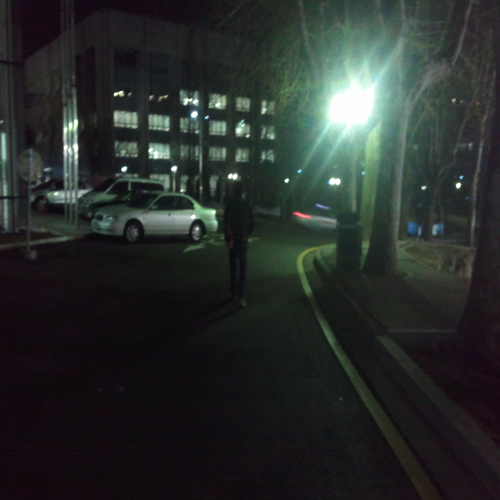Is the overall clarity of the image low? Indeed, the overall clarity of the image is low; it appears to be taken at night with limited lighting, resulting in shadows and a lack of detail which affects the image sharpness. 